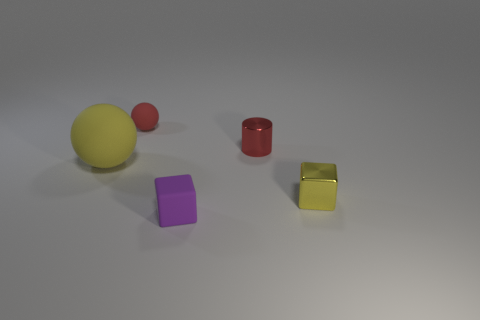Add 5 purple cubes. How many objects exist? 10 Subtract all cubes. How many objects are left? 3 Add 1 small red things. How many small red things exist? 3 Subtract 0 blue spheres. How many objects are left? 5 Subtract all purple cubes. Subtract all small shiny cubes. How many objects are left? 3 Add 4 red objects. How many red objects are left? 6 